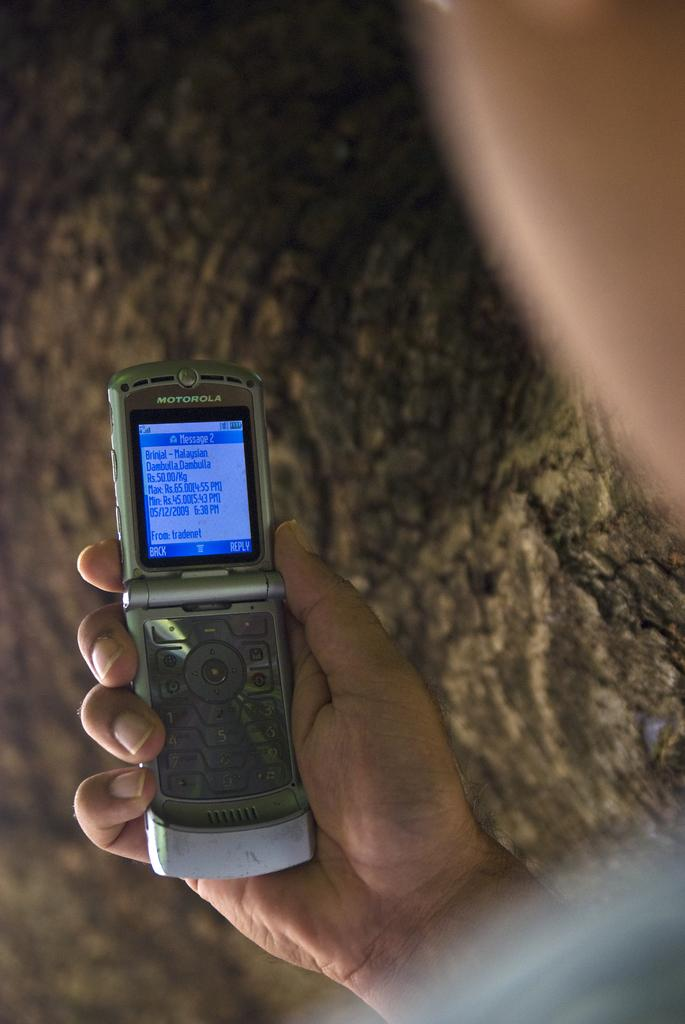<image>
Describe the image concisely. Someone is holding an open Motorola phone in their hand. 